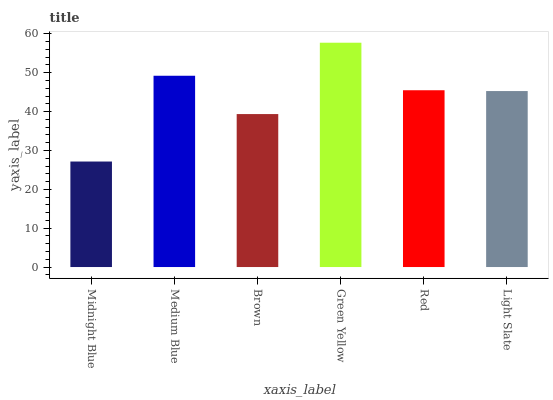Is Midnight Blue the minimum?
Answer yes or no. Yes. Is Green Yellow the maximum?
Answer yes or no. Yes. Is Medium Blue the minimum?
Answer yes or no. No. Is Medium Blue the maximum?
Answer yes or no. No. Is Medium Blue greater than Midnight Blue?
Answer yes or no. Yes. Is Midnight Blue less than Medium Blue?
Answer yes or no. Yes. Is Midnight Blue greater than Medium Blue?
Answer yes or no. No. Is Medium Blue less than Midnight Blue?
Answer yes or no. No. Is Red the high median?
Answer yes or no. Yes. Is Light Slate the low median?
Answer yes or no. Yes. Is Medium Blue the high median?
Answer yes or no. No. Is Green Yellow the low median?
Answer yes or no. No. 